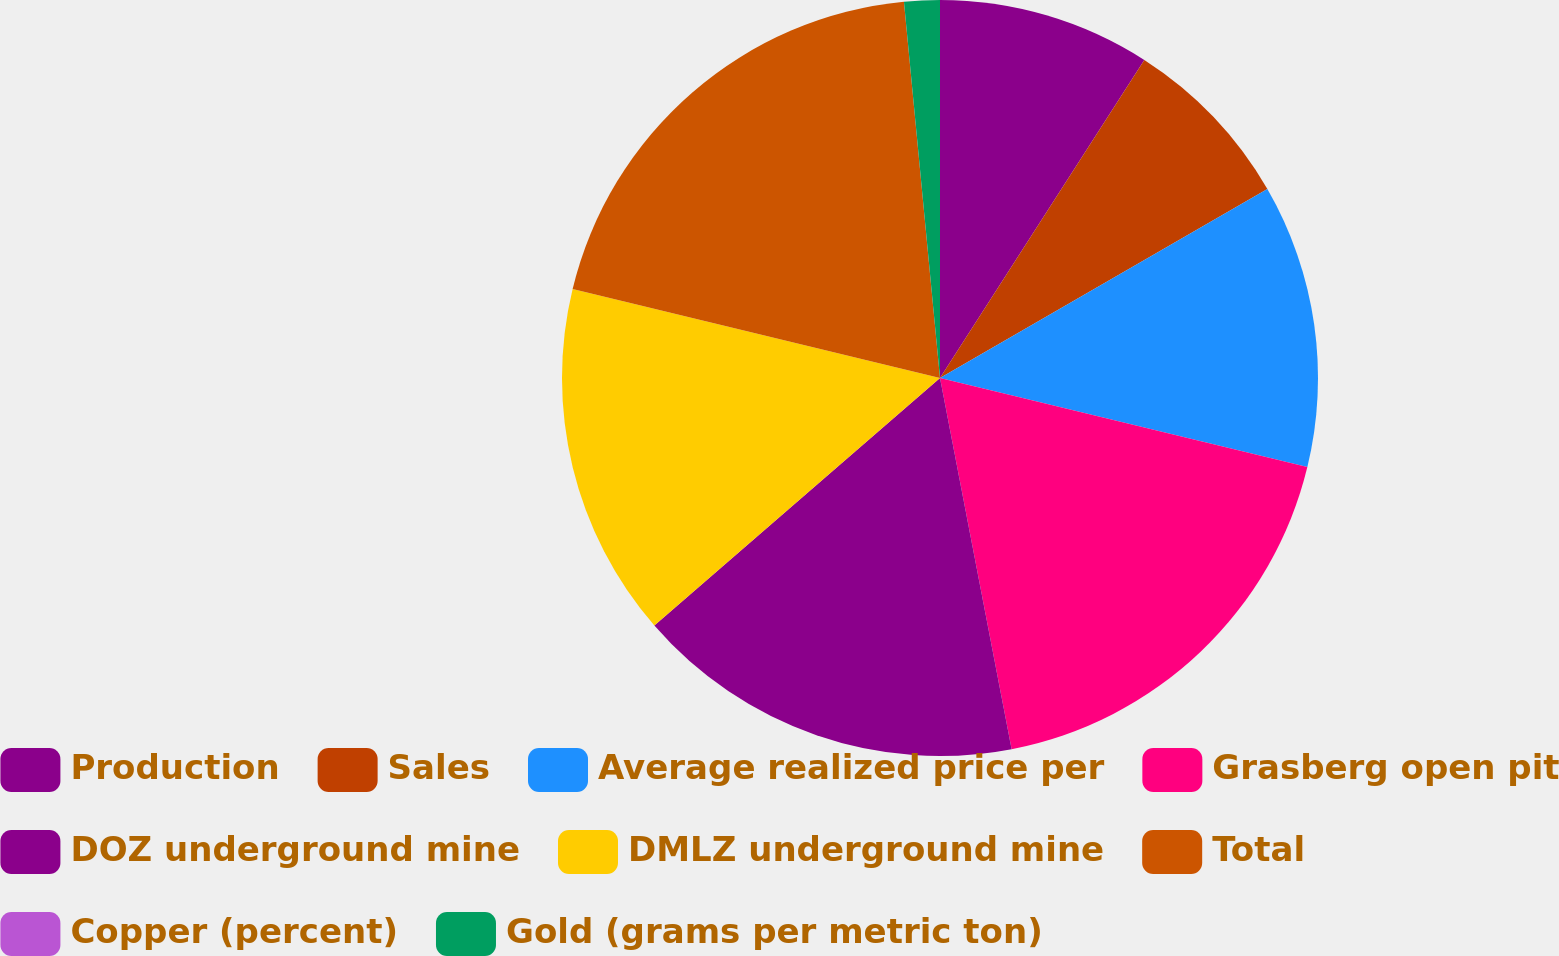Convert chart. <chart><loc_0><loc_0><loc_500><loc_500><pie_chart><fcel>Production<fcel>Sales<fcel>Average realized price per<fcel>Grasberg open pit<fcel>DOZ underground mine<fcel>DMLZ underground mine<fcel>Total<fcel>Copper (percent)<fcel>Gold (grams per metric ton)<nl><fcel>9.09%<fcel>7.58%<fcel>12.12%<fcel>18.18%<fcel>16.67%<fcel>15.15%<fcel>19.7%<fcel>0.0%<fcel>1.52%<nl></chart> 